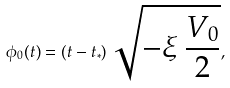<formula> <loc_0><loc_0><loc_500><loc_500>\phi _ { 0 } ( t ) = ( t - t _ { * } ) \, \sqrt { - \xi \, \frac { V _ { 0 } } { 2 } } ,</formula> 